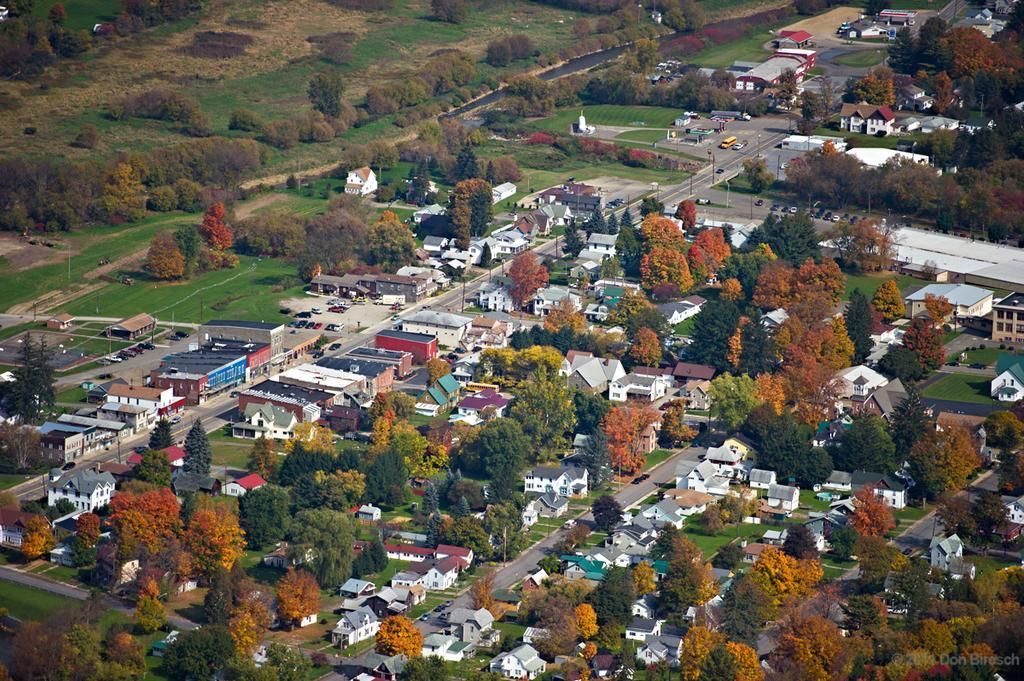Could you give a brief overview of what you see in this image? This image is an aerial view. In this image we can see many buildings and trees. There are roads and we can see vehicles. 